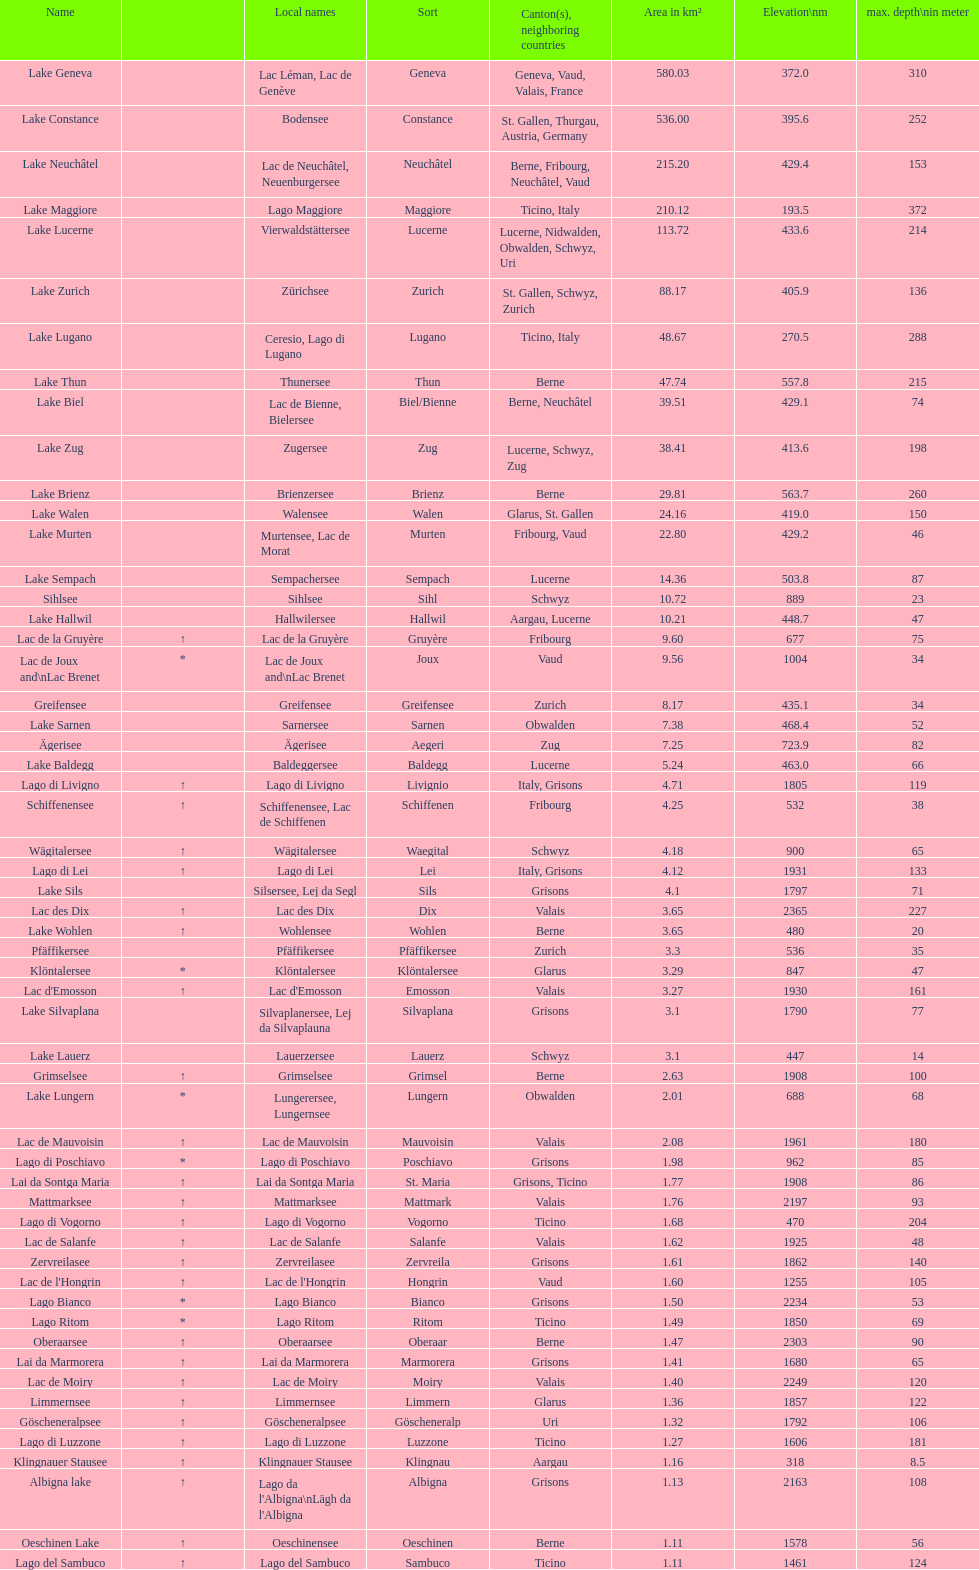What is the combined total depth of the three deepest lakes? 970. 